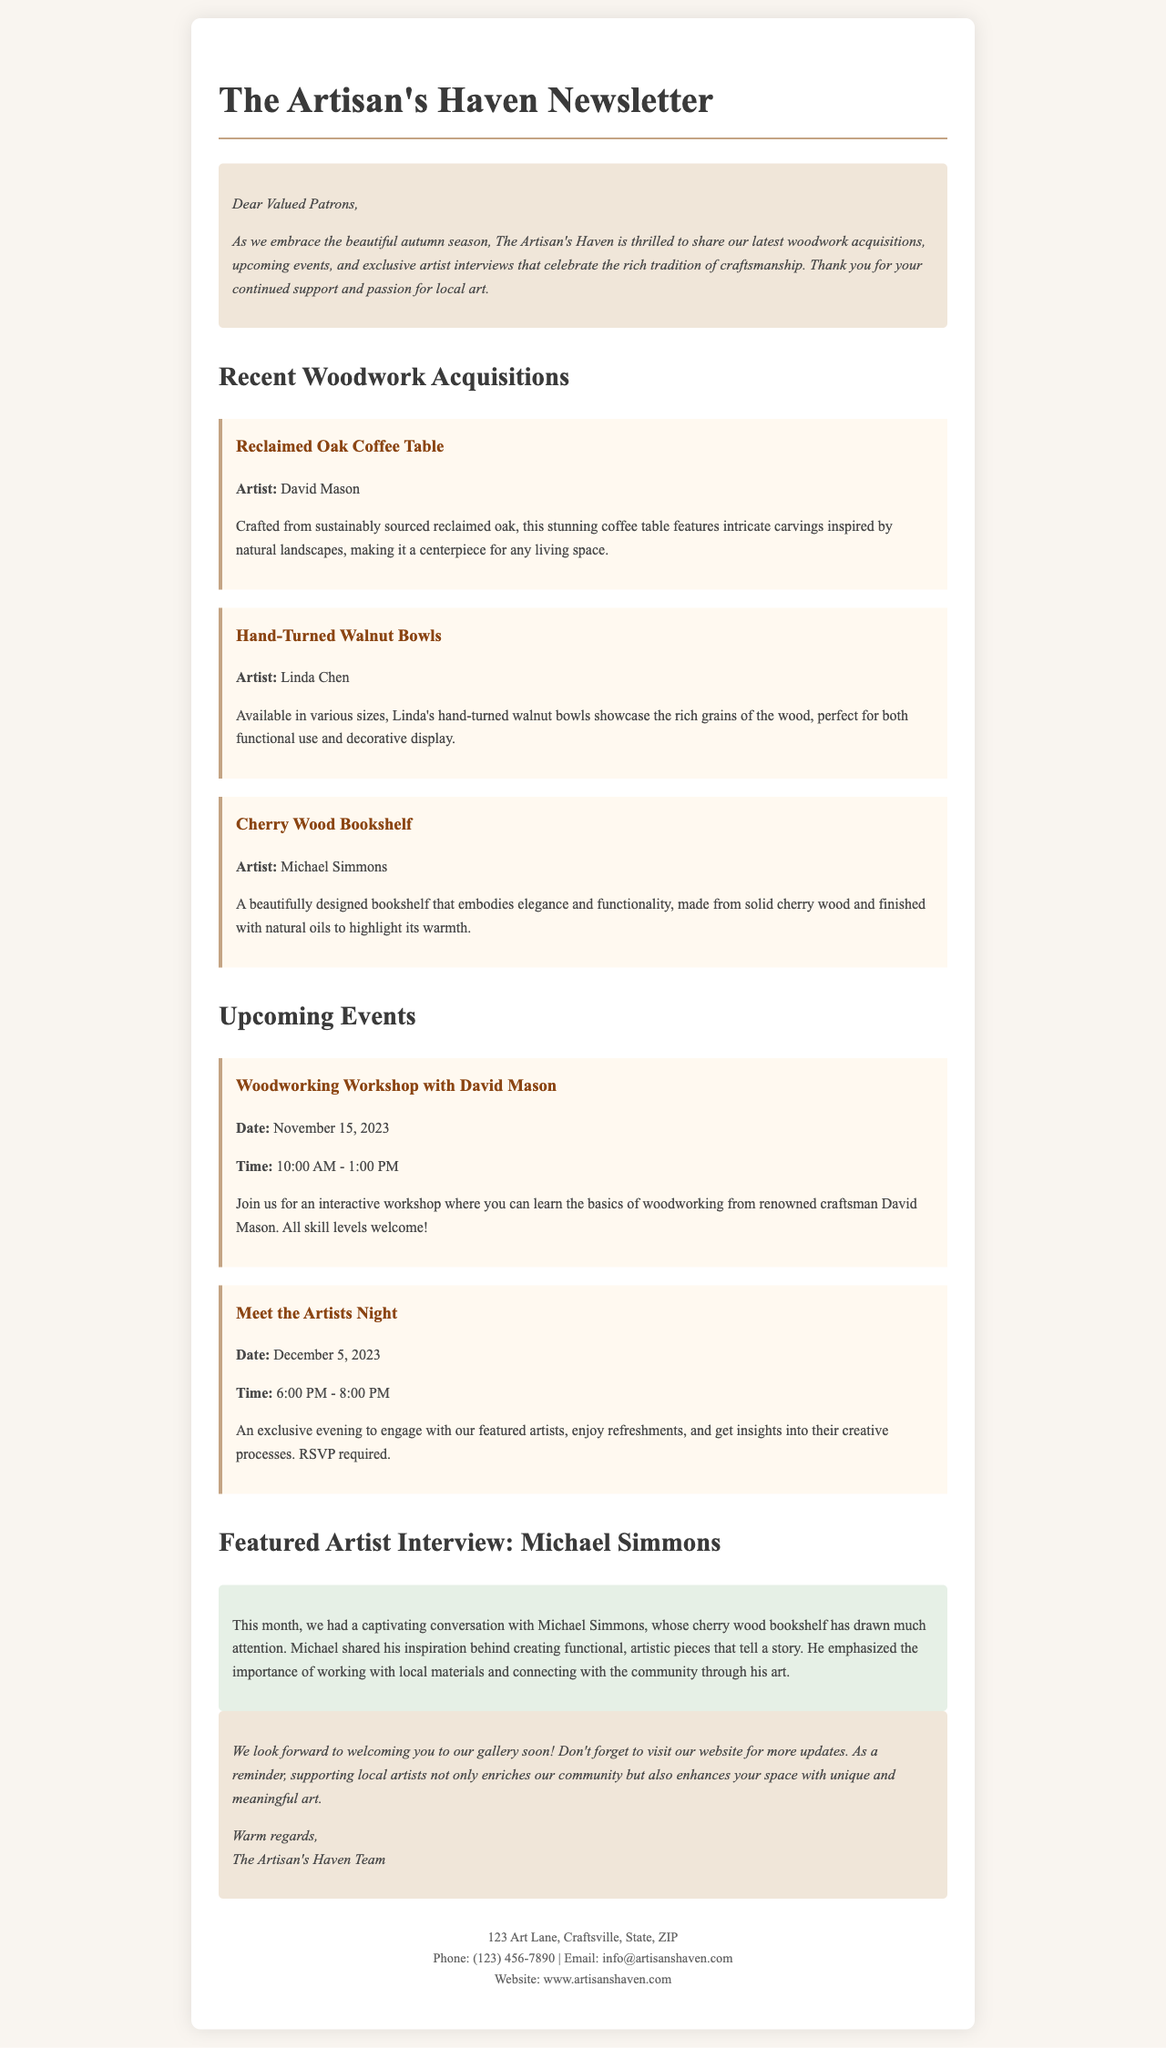what is the name of the newsletter? The title of the newsletter is stated at the top of the document.
Answer: The Artisan's Haven Newsletter who is the artist of the Reclaimed Oak Coffee Table? The document provides the name of the artist associated with this woodwork acquisition.
Answer: David Mason what is the date of the woodworking workshop? The document includes the date of the upcoming woodworking workshop event.
Answer: November 15, 2023 how many sizes are available for the Hand-Turned Walnut Bowls? The text mentions that the bowls come in various sizes but does not specify a number.
Answer: Various sizes what is the location of The Artisan's Haven? The contact section of the document lists the address of the gallery.
Answer: 123 Art Lane, Craftsville, State, ZIP what is the emphasis of Michael Simmons in his interview? The reasoning behind the artist's creative process is mentioned in his interview with highlights.
Answer: Importance of working with local materials what time does the Meet the Artists Night start? The event section specifies the starting time for this particular event.
Answer: 6:00 PM who crafted the Cherry Wood Bookshelf? The artist who created this woodwork acquisition is clearly listed in the document.
Answer: Michael Simmons what type of workshop is being held on November 15, 2023? The nature of the upcoming event involving David Mason is elaborated in the event description.
Answer: Woodworking Workshop 